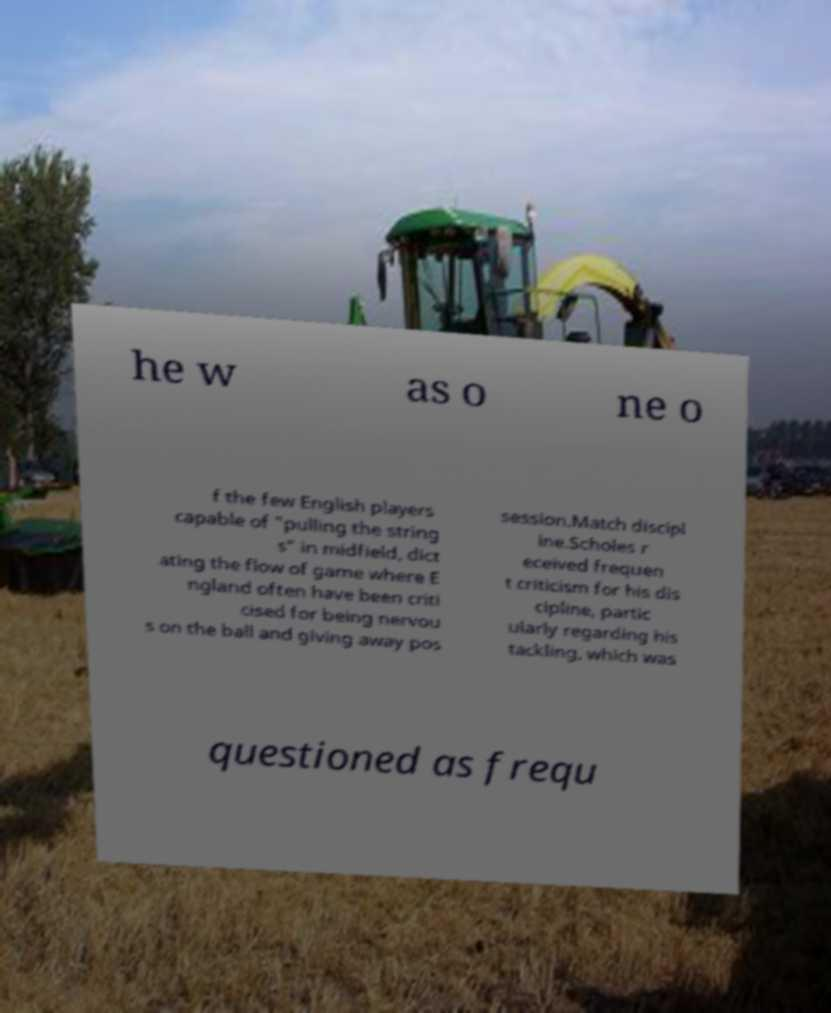Please identify and transcribe the text found in this image. he w as o ne o f the few English players capable of "pulling the string s" in midfield, dict ating the flow of game where E ngland often have been criti cised for being nervou s on the ball and giving away pos session.Match discipl ine.Scholes r eceived frequen t criticism for his dis cipline, partic ularly regarding his tackling, which was questioned as frequ 